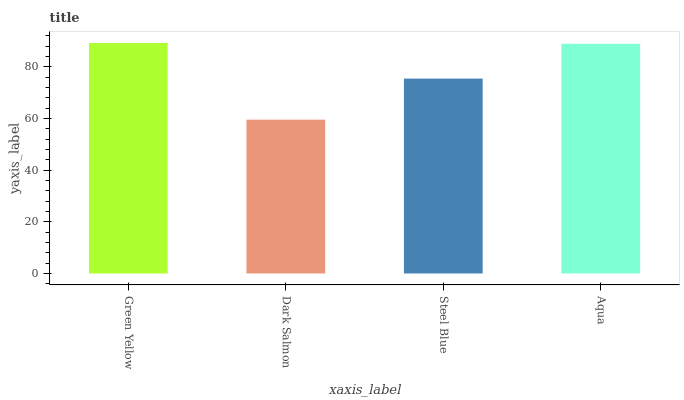Is Dark Salmon the minimum?
Answer yes or no. Yes. Is Green Yellow the maximum?
Answer yes or no. Yes. Is Steel Blue the minimum?
Answer yes or no. No. Is Steel Blue the maximum?
Answer yes or no. No. Is Steel Blue greater than Dark Salmon?
Answer yes or no. Yes. Is Dark Salmon less than Steel Blue?
Answer yes or no. Yes. Is Dark Salmon greater than Steel Blue?
Answer yes or no. No. Is Steel Blue less than Dark Salmon?
Answer yes or no. No. Is Aqua the high median?
Answer yes or no. Yes. Is Steel Blue the low median?
Answer yes or no. Yes. Is Green Yellow the high median?
Answer yes or no. No. Is Aqua the low median?
Answer yes or no. No. 